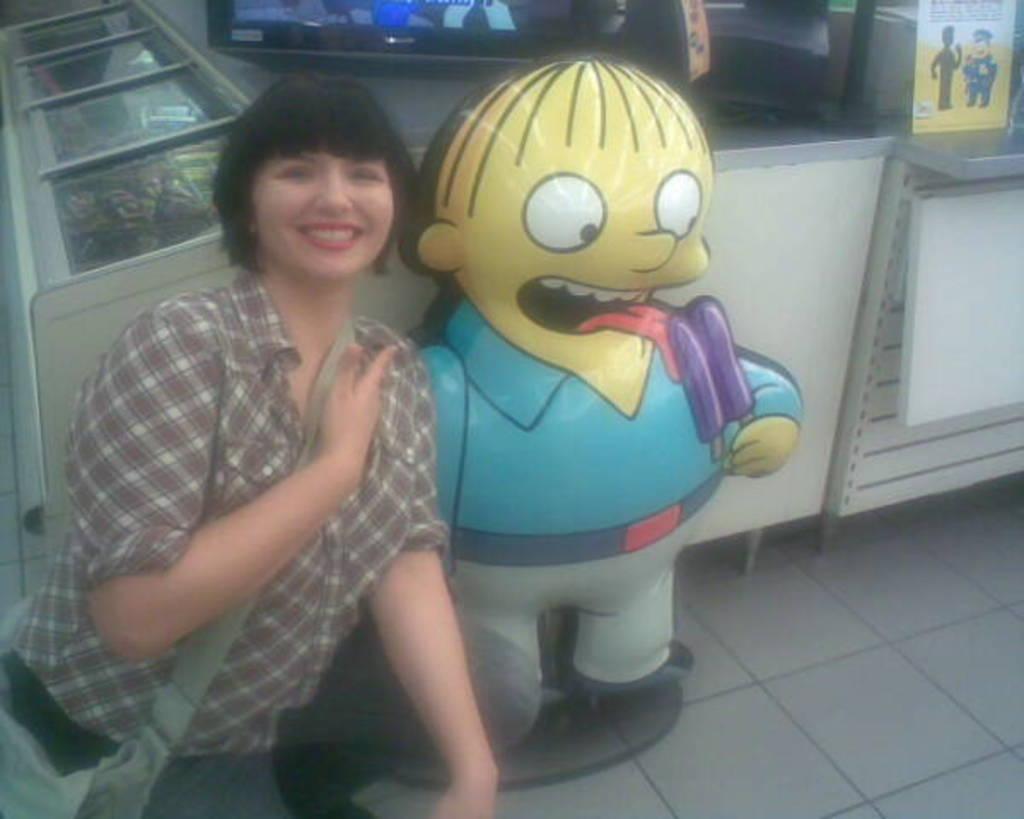Could you give a brief overview of what you see in this image? This is the woman sitting in the squat position and smiling. She wore a shirt, trouser and a bag. This looks like an inflatable balloon of a boy holding and ice pop. These are the glass doors. I think this is a television. I can see the board, which is attached to the wooden board. 